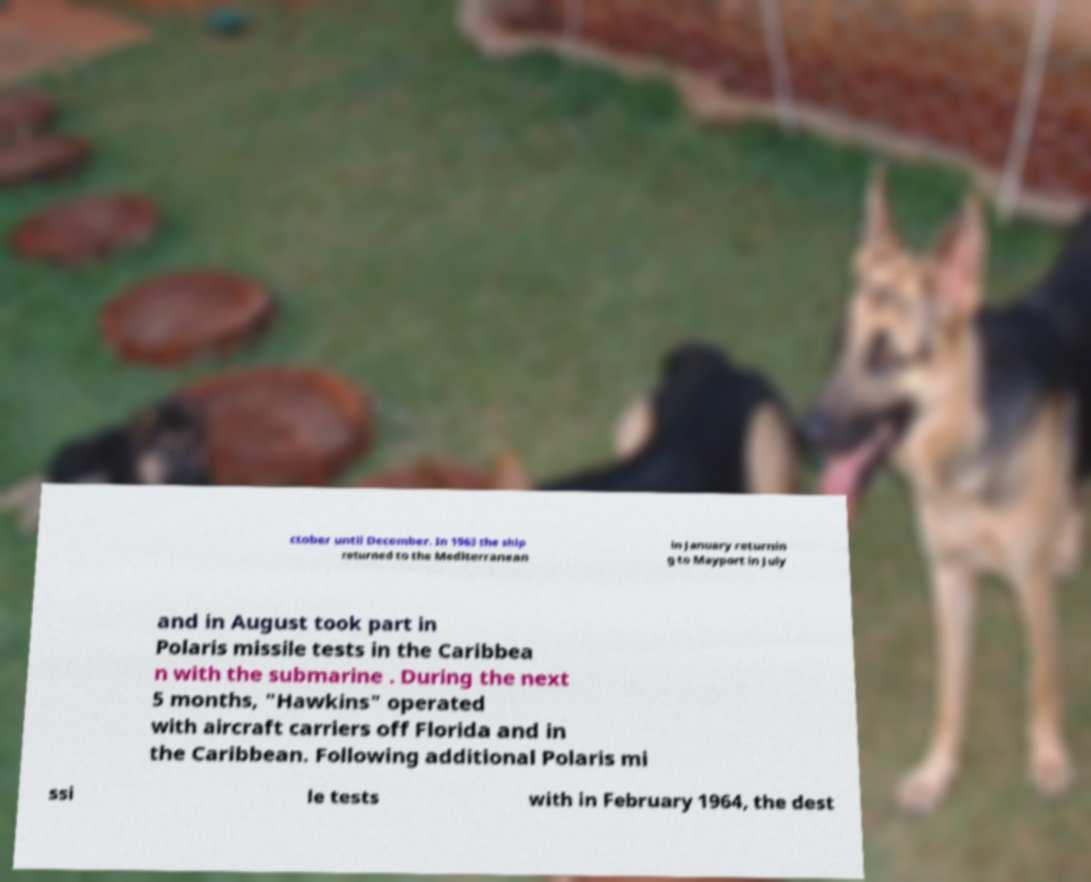Could you assist in decoding the text presented in this image and type it out clearly? ctober until December. In 1963 the ship returned to the Mediterranean in January returnin g to Mayport in July and in August took part in Polaris missile tests in the Caribbea n with the submarine . During the next 5 months, "Hawkins" operated with aircraft carriers off Florida and in the Caribbean. Following additional Polaris mi ssi le tests with in February 1964, the dest 